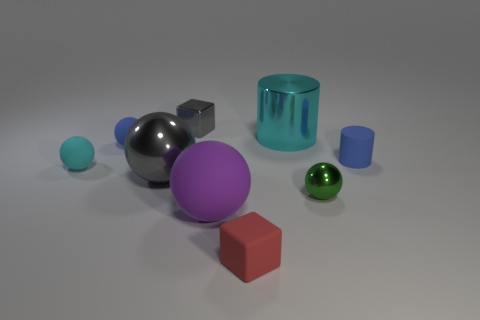How many other shiny objects are the same shape as the green object?
Your response must be concise. 1. The green object that is the same material as the large cyan cylinder is what shape?
Keep it short and to the point. Sphere. There is a big object behind the blue thing on the right side of the tiny rubber sphere that is right of the tiny cyan thing; what is its material?
Provide a short and direct response. Metal. There is a gray metal cube; is it the same size as the gray metal object that is in front of the cyan matte thing?
Keep it short and to the point. No. What is the material of the small cyan thing that is the same shape as the purple object?
Offer a terse response. Rubber. There is a shiny sphere that is on the right side of the large thing that is on the left side of the tiny object that is behind the small blue ball; what is its size?
Give a very brief answer. Small. Do the metal cylinder and the rubber cylinder have the same size?
Your answer should be compact. No. Is the number of gray metal objects the same as the number of cyan cylinders?
Provide a succinct answer. No. There is a blue thing that is on the left side of the block left of the purple thing; what is it made of?
Ensure brevity in your answer.  Rubber. Is the shape of the small object in front of the purple matte thing the same as the cyan object on the left side of the small metal cube?
Your answer should be very brief. No. 